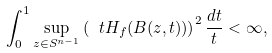<formula> <loc_0><loc_0><loc_500><loc_500>\int _ { 0 } ^ { 1 } \sup _ { z \in S ^ { n - 1 } } \left ( \ t H _ { f } ( B ( z , t ) ) \right ) ^ { 2 } \frac { d t } { t } < \infty ,</formula> 